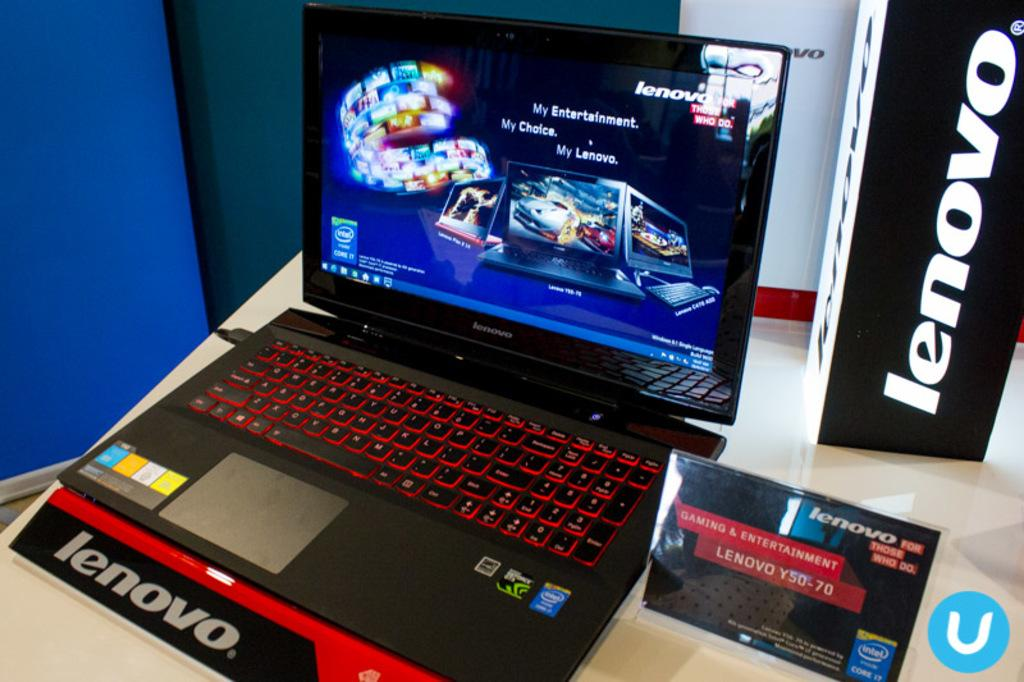What electronic device is visible in the image? There is a laptop in the image. Where is the laptop located? The laptop is on a table. What can be seen in the background of the image? There is a wall in the background of the image. What type of seed is being planted in the image? There is no seed or planting activity present in the image; it features a laptop on a table with a wall in the background. 